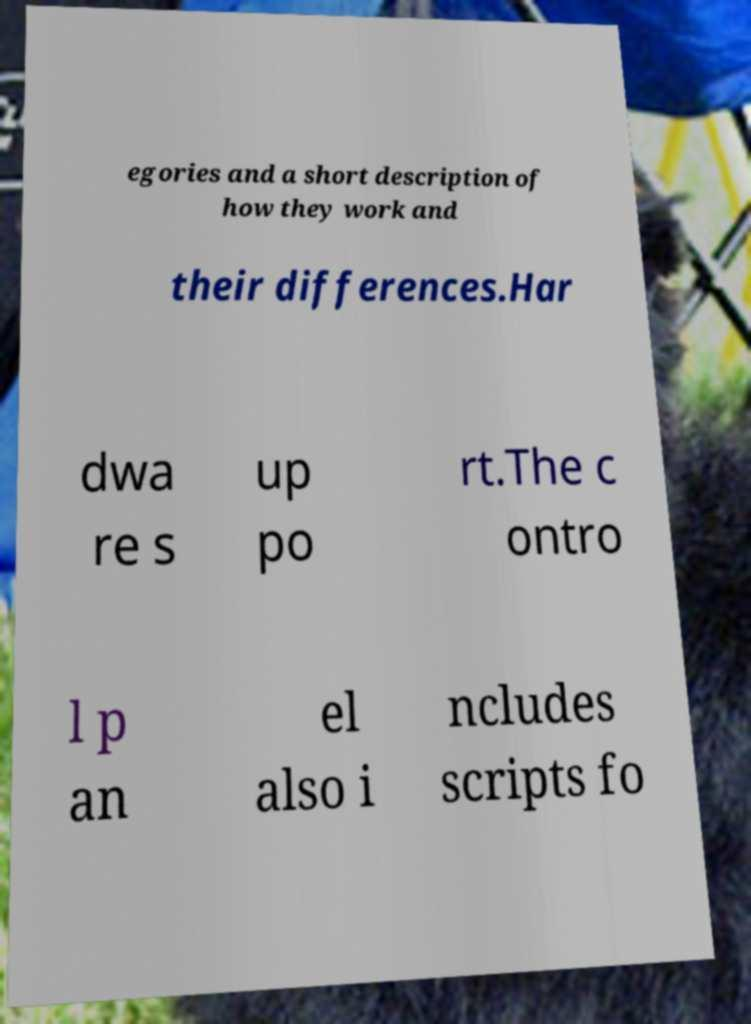What messages or text are displayed in this image? I need them in a readable, typed format. egories and a short description of how they work and their differences.Har dwa re s up po rt.The c ontro l p an el also i ncludes scripts fo 